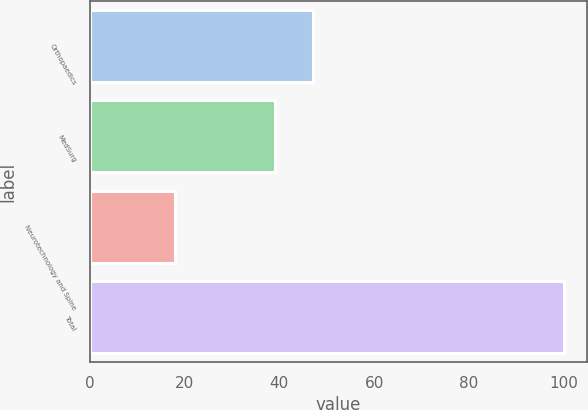<chart> <loc_0><loc_0><loc_500><loc_500><bar_chart><fcel>Orthopaedics<fcel>MedSurg<fcel>Neurotechnology and Spine<fcel>Total<nl><fcel>47.2<fcel>39<fcel>18<fcel>100<nl></chart> 